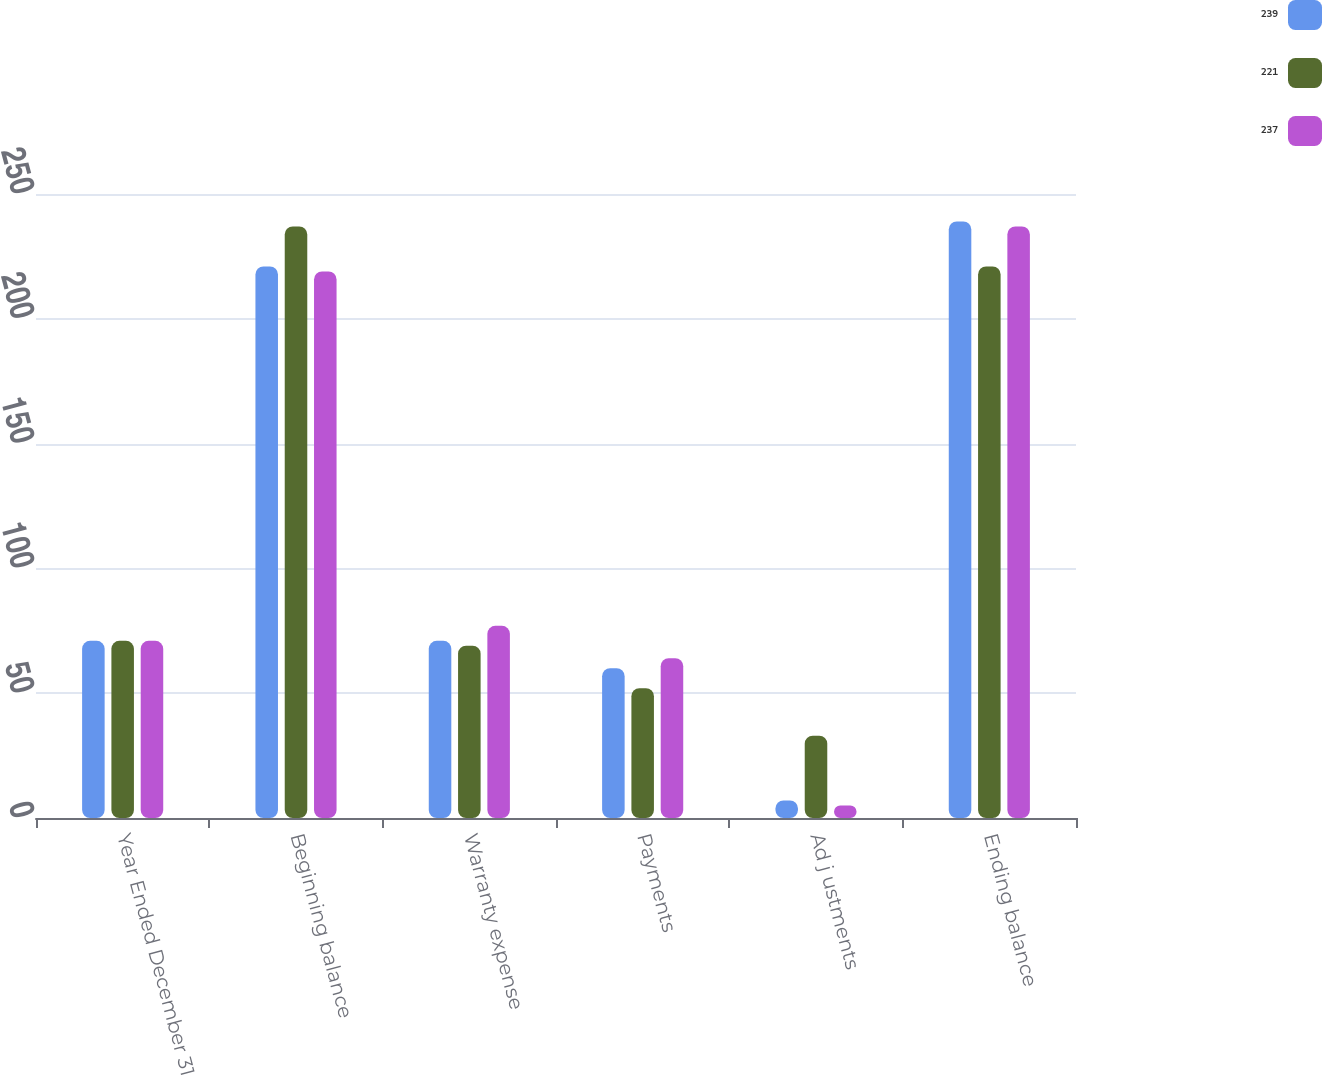<chart> <loc_0><loc_0><loc_500><loc_500><stacked_bar_chart><ecel><fcel>Year Ended December 31<fcel>Beginning balance<fcel>Warranty expense<fcel>Payments<fcel>Ad j ustments<fcel>Ending balance<nl><fcel>239<fcel>71<fcel>221<fcel>71<fcel>60<fcel>7<fcel>239<nl><fcel>221<fcel>71<fcel>237<fcel>69<fcel>52<fcel>33<fcel>221<nl><fcel>237<fcel>71<fcel>219<fcel>77<fcel>64<fcel>5<fcel>237<nl></chart> 